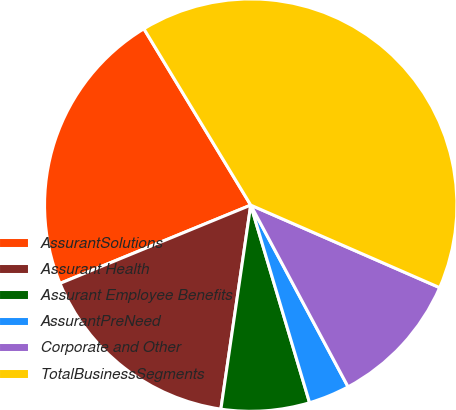Convert chart. <chart><loc_0><loc_0><loc_500><loc_500><pie_chart><fcel>AssurantSolutions<fcel>Assurant Health<fcel>Assurant Employee Benefits<fcel>AssurantPreNeed<fcel>Corporate and Other<fcel>TotalBusinessSegments<nl><fcel>22.53%<fcel>16.49%<fcel>6.92%<fcel>3.22%<fcel>10.62%<fcel>40.23%<nl></chart> 